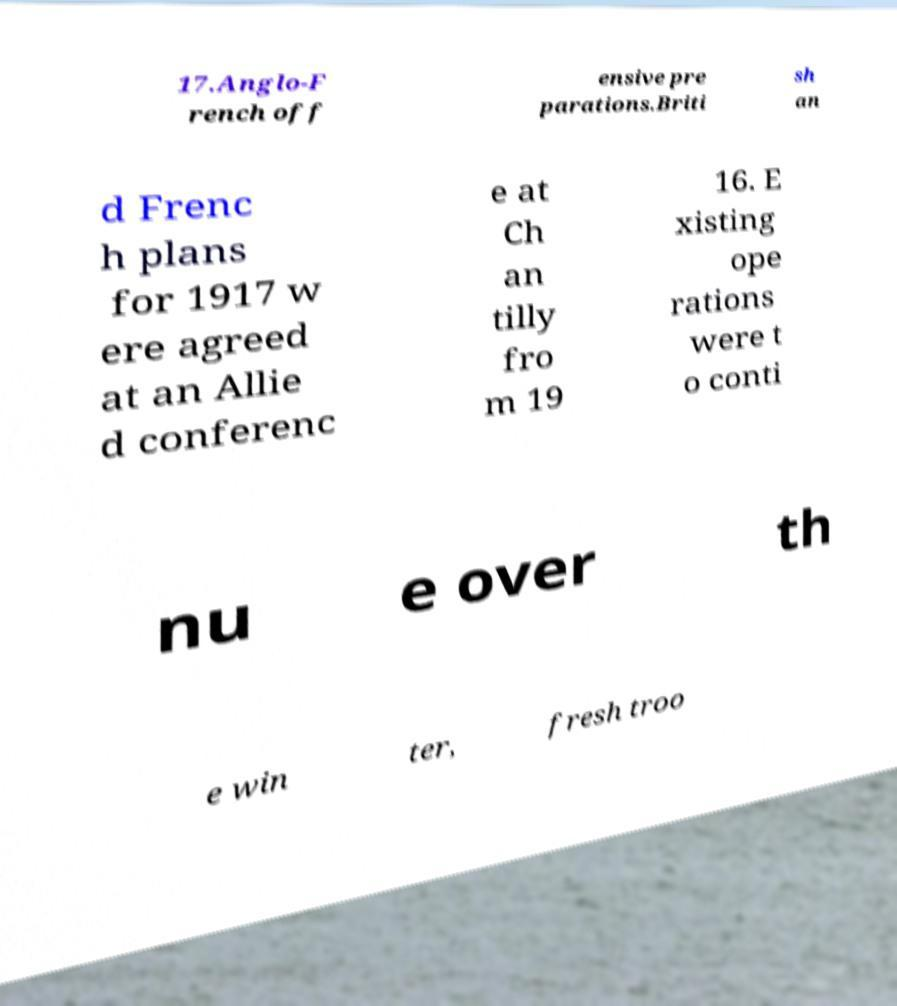Could you extract and type out the text from this image? 17.Anglo-F rench off ensive pre parations.Briti sh an d Frenc h plans for 1917 w ere agreed at an Allie d conferenc e at Ch an tilly fro m 19 16. E xisting ope rations were t o conti nu e over th e win ter, fresh troo 